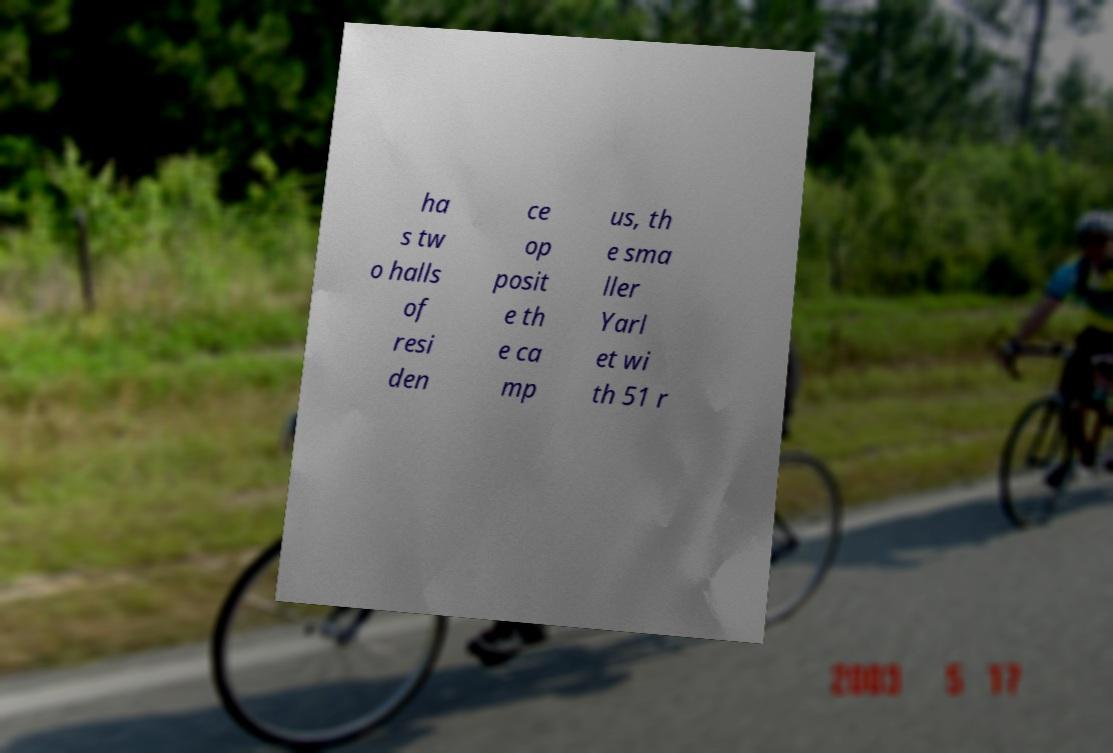Can you accurately transcribe the text from the provided image for me? ha s tw o halls of resi den ce op posit e th e ca mp us, th e sma ller Yarl et wi th 51 r 